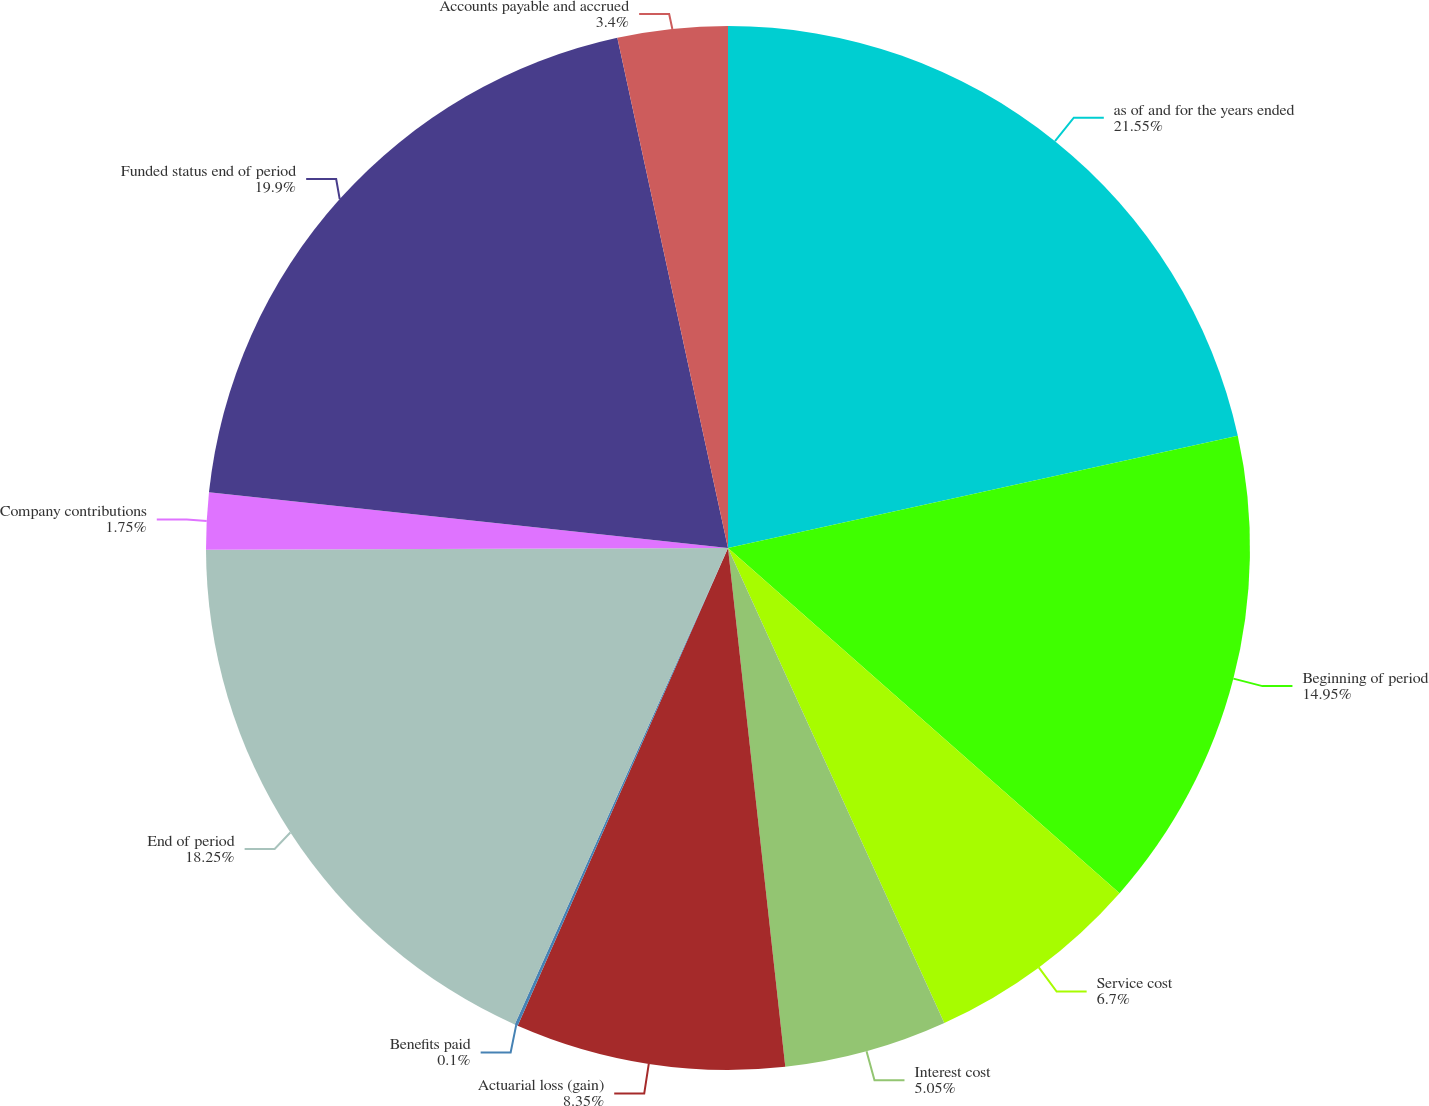Convert chart. <chart><loc_0><loc_0><loc_500><loc_500><pie_chart><fcel>as of and for the years ended<fcel>Beginning of period<fcel>Service cost<fcel>Interest cost<fcel>Actuarial loss (gain)<fcel>Benefits paid<fcel>End of period<fcel>Company contributions<fcel>Funded status end of period<fcel>Accounts payable and accrued<nl><fcel>21.55%<fcel>14.95%<fcel>6.7%<fcel>5.05%<fcel>8.35%<fcel>0.1%<fcel>18.25%<fcel>1.75%<fcel>19.9%<fcel>3.4%<nl></chart> 